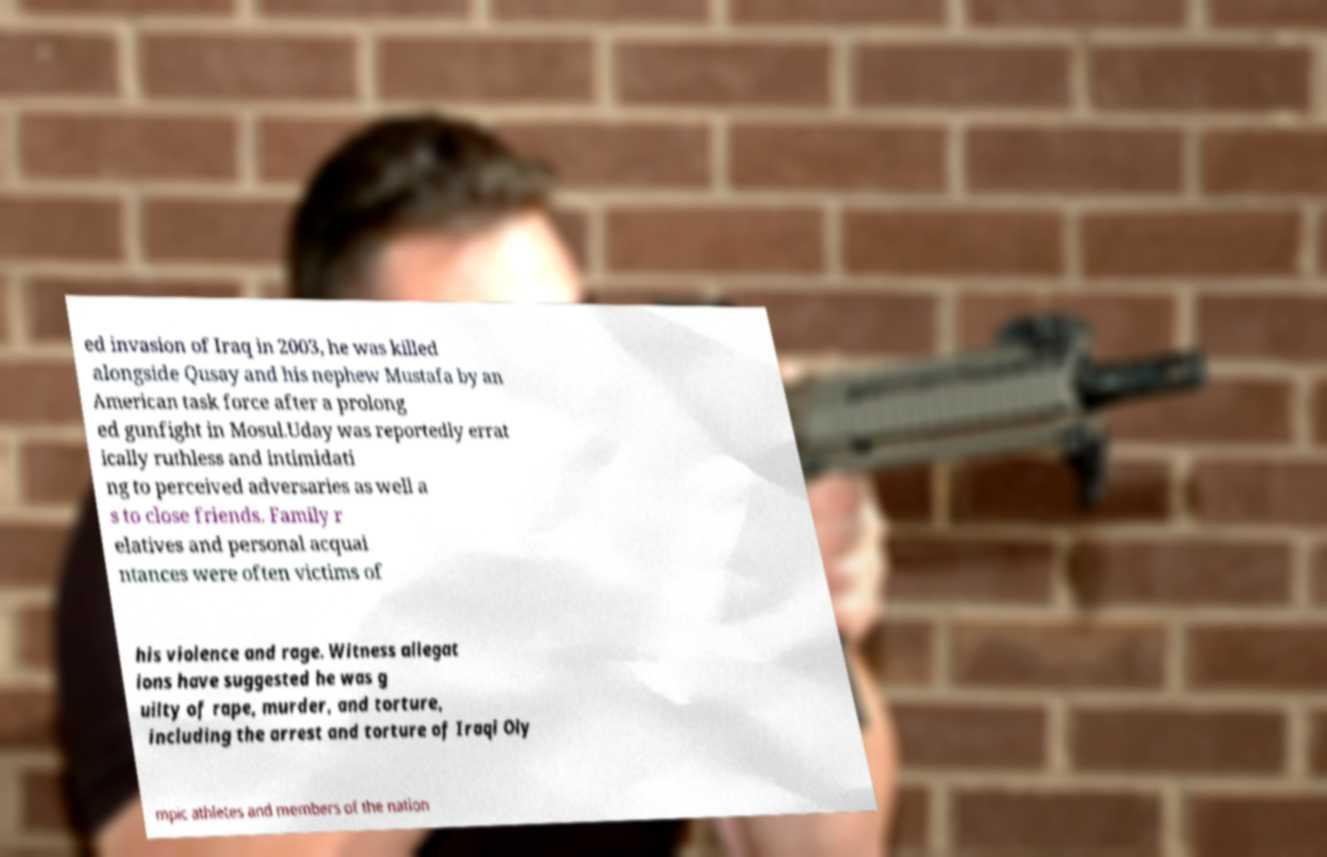Could you extract and type out the text from this image? ed invasion of Iraq in 2003, he was killed alongside Qusay and his nephew Mustafa by an American task force after a prolong ed gunfight in Mosul.Uday was reportedly errat ically ruthless and intimidati ng to perceived adversaries as well a s to close friends. Family r elatives and personal acquai ntances were often victims of his violence and rage. Witness allegat ions have suggested he was g uilty of rape, murder, and torture, including the arrest and torture of Iraqi Oly mpic athletes and members of the nation 